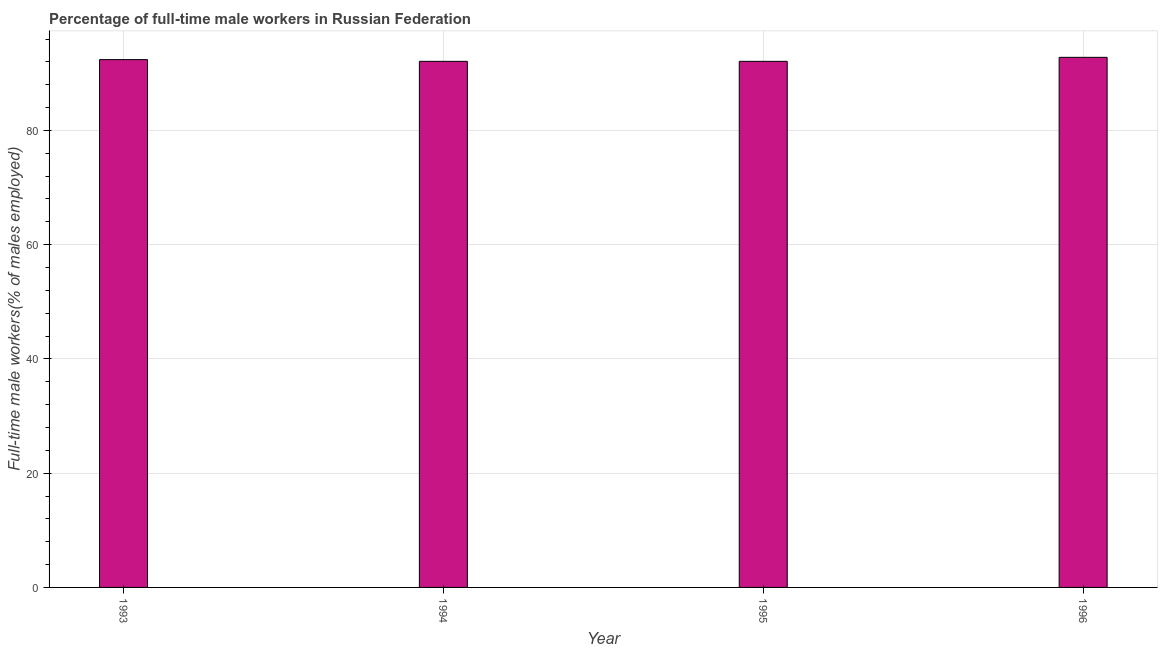Does the graph contain grids?
Offer a terse response. Yes. What is the title of the graph?
Make the answer very short. Percentage of full-time male workers in Russian Federation. What is the label or title of the X-axis?
Your response must be concise. Year. What is the label or title of the Y-axis?
Provide a short and direct response. Full-time male workers(% of males employed). What is the percentage of full-time male workers in 1995?
Provide a short and direct response. 92.1. Across all years, what is the maximum percentage of full-time male workers?
Give a very brief answer. 92.8. Across all years, what is the minimum percentage of full-time male workers?
Your answer should be very brief. 92.1. In which year was the percentage of full-time male workers maximum?
Your answer should be very brief. 1996. In which year was the percentage of full-time male workers minimum?
Your answer should be compact. 1994. What is the sum of the percentage of full-time male workers?
Make the answer very short. 369.4. What is the average percentage of full-time male workers per year?
Provide a succinct answer. 92.35. What is the median percentage of full-time male workers?
Keep it short and to the point. 92.25. Is the percentage of full-time male workers in 1994 less than that in 1995?
Your response must be concise. No. Is the sum of the percentage of full-time male workers in 1993 and 1996 greater than the maximum percentage of full-time male workers across all years?
Your response must be concise. Yes. In how many years, is the percentage of full-time male workers greater than the average percentage of full-time male workers taken over all years?
Offer a terse response. 2. How many bars are there?
Your answer should be very brief. 4. What is the difference between two consecutive major ticks on the Y-axis?
Make the answer very short. 20. What is the Full-time male workers(% of males employed) of 1993?
Ensure brevity in your answer.  92.4. What is the Full-time male workers(% of males employed) of 1994?
Give a very brief answer. 92.1. What is the Full-time male workers(% of males employed) of 1995?
Offer a terse response. 92.1. What is the Full-time male workers(% of males employed) in 1996?
Offer a very short reply. 92.8. What is the difference between the Full-time male workers(% of males employed) in 1993 and 1994?
Your answer should be compact. 0.3. What is the difference between the Full-time male workers(% of males employed) in 1993 and 1995?
Give a very brief answer. 0.3. What is the difference between the Full-time male workers(% of males employed) in 1993 and 1996?
Your answer should be compact. -0.4. What is the difference between the Full-time male workers(% of males employed) in 1994 and 1995?
Your response must be concise. 0. What is the difference between the Full-time male workers(% of males employed) in 1995 and 1996?
Offer a terse response. -0.7. What is the ratio of the Full-time male workers(% of males employed) in 1993 to that in 1996?
Offer a very short reply. 1. What is the ratio of the Full-time male workers(% of males employed) in 1994 to that in 1995?
Your answer should be very brief. 1. What is the ratio of the Full-time male workers(% of males employed) in 1995 to that in 1996?
Provide a succinct answer. 0.99. 